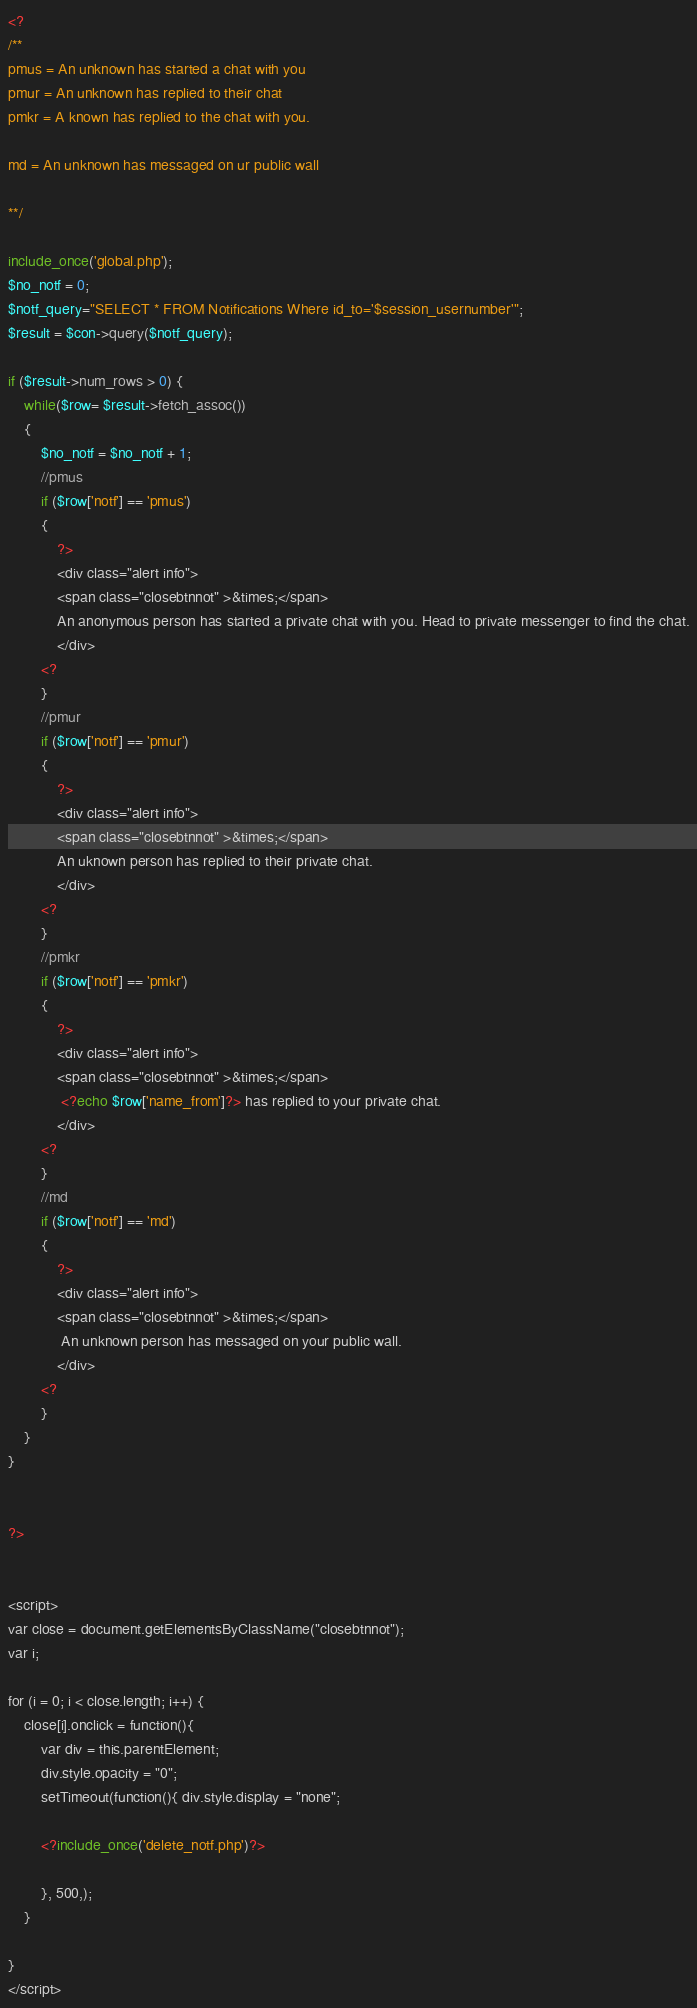<code> <loc_0><loc_0><loc_500><loc_500><_PHP_><?
/**
pmus = An unknown has started a chat with you
pmur = An unknown has replied to their chat
pmkr = A known has replied to the chat with you.

md = An unknown has messaged on ur public wall

**/

include_once('global.php');
$no_notf = 0;
$notf_query="SELECT * FROM Notifications Where id_to='$session_usernumber'";
$result = $con->query($notf_query);

if ($result->num_rows > 0) {
    while($row= $result->fetch_assoc())
    {
        $no_notf = $no_notf + 1;
        //pmus
        if ($row['notf'] == 'pmus')
        {
            ?>
            <div class="alert info">
            <span class="closebtnnot" >&times;</span>  
            An anonymous person has started a private chat with you. Head to private messenger to find the chat.
            </div>
        <?
        }
        //pmur
        if ($row['notf'] == 'pmur')
        {
            ?>
            <div class="alert info">
            <span class="closebtnnot" >&times;</span>  
            An uknown person has replied to their private chat.
            </div>
        <?
        }
        //pmkr
        if ($row['notf'] == 'pmkr')
        {
            ?>
            <div class="alert info">
            <span class="closebtnnot" >&times;</span>  
             <?echo $row['name_from']?> has replied to your private chat.
            </div>
        <?
        }
        //md
        if ($row['notf'] == 'md')
        {
            ?>
            <div class="alert info">
            <span class="closebtnnot" >&times;</span>  
             An unknown person has messaged on your public wall.
            </div>
        <?
        }
    }
}
   

?>


<script>
var close = document.getElementsByClassName("closebtnnot");
var i;

for (i = 0; i < close.length; i++) {
    close[i].onclick = function(){
        var div = this.parentElement;
        div.style.opacity = "0";
        setTimeout(function(){ div.style.display = "none"; 

        <?include_once('delete_notf.php')?>
            
        }, 500,);
    }
    
}
</script>
</code> 